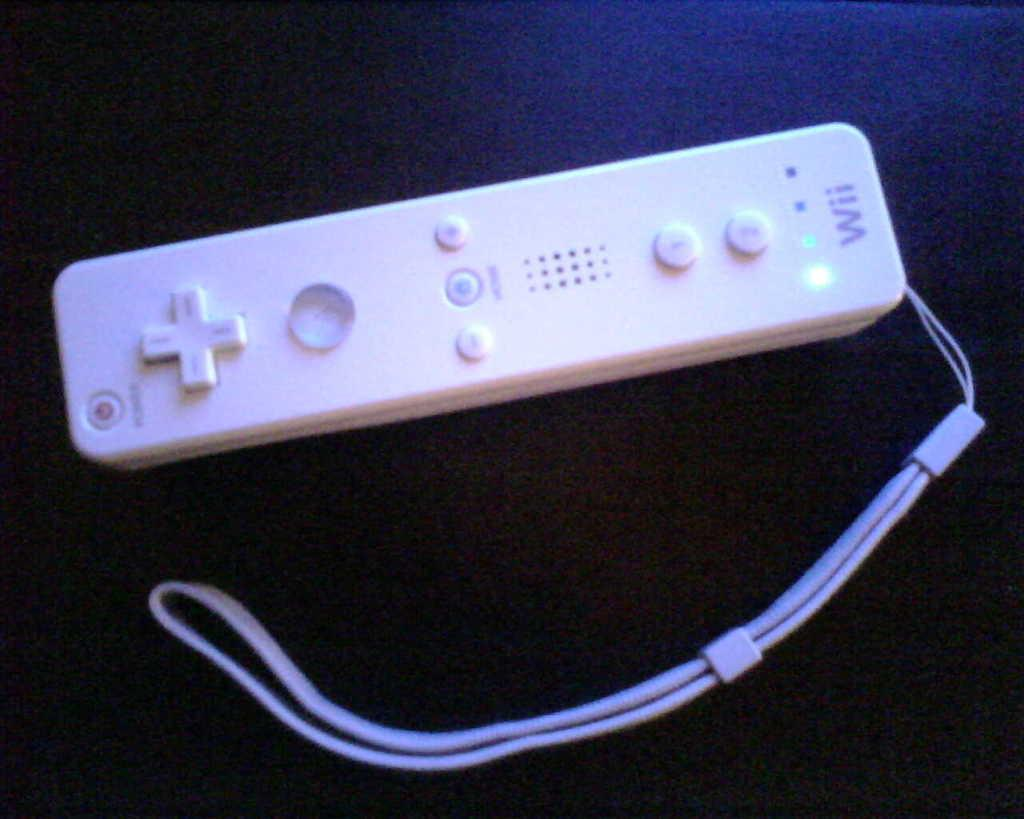<image>
Render a clear and concise summary of the photo. a Nintendo Wii remote that has an arm band 